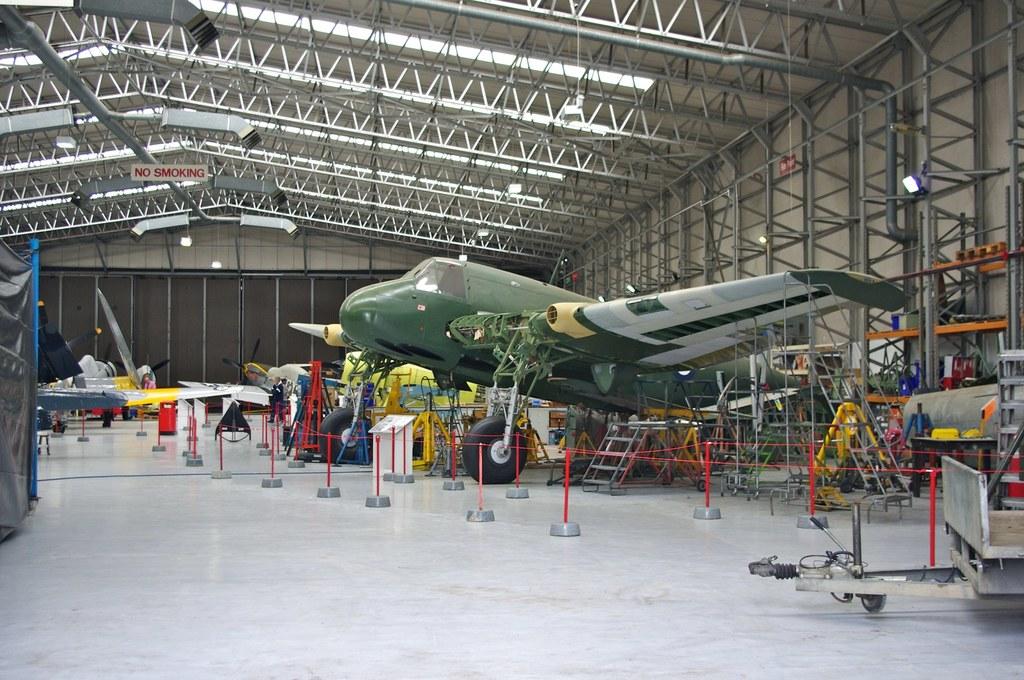The sign on the ceiling says what is not allowed?
Keep it short and to the point. Smoking. Is smoking allowed?
Ensure brevity in your answer.  No. 